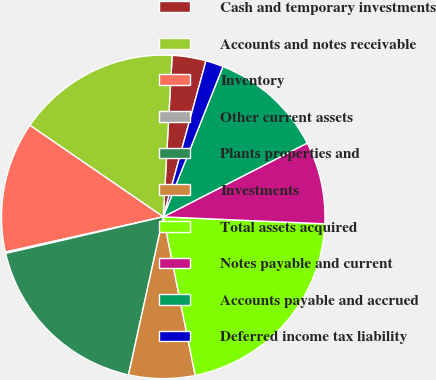<chart> <loc_0><loc_0><loc_500><loc_500><pie_chart><fcel>Cash and temporary investments<fcel>Accounts and notes receivable<fcel>Inventory<fcel>Other current assets<fcel>Plants properties and<fcel>Investments<fcel>Total assets acquired<fcel>Notes payable and current<fcel>Accounts payable and accrued<fcel>Deferred income tax liability<nl><fcel>3.38%<fcel>16.3%<fcel>13.07%<fcel>0.14%<fcel>17.92%<fcel>6.61%<fcel>21.15%<fcel>8.22%<fcel>11.45%<fcel>1.76%<nl></chart> 